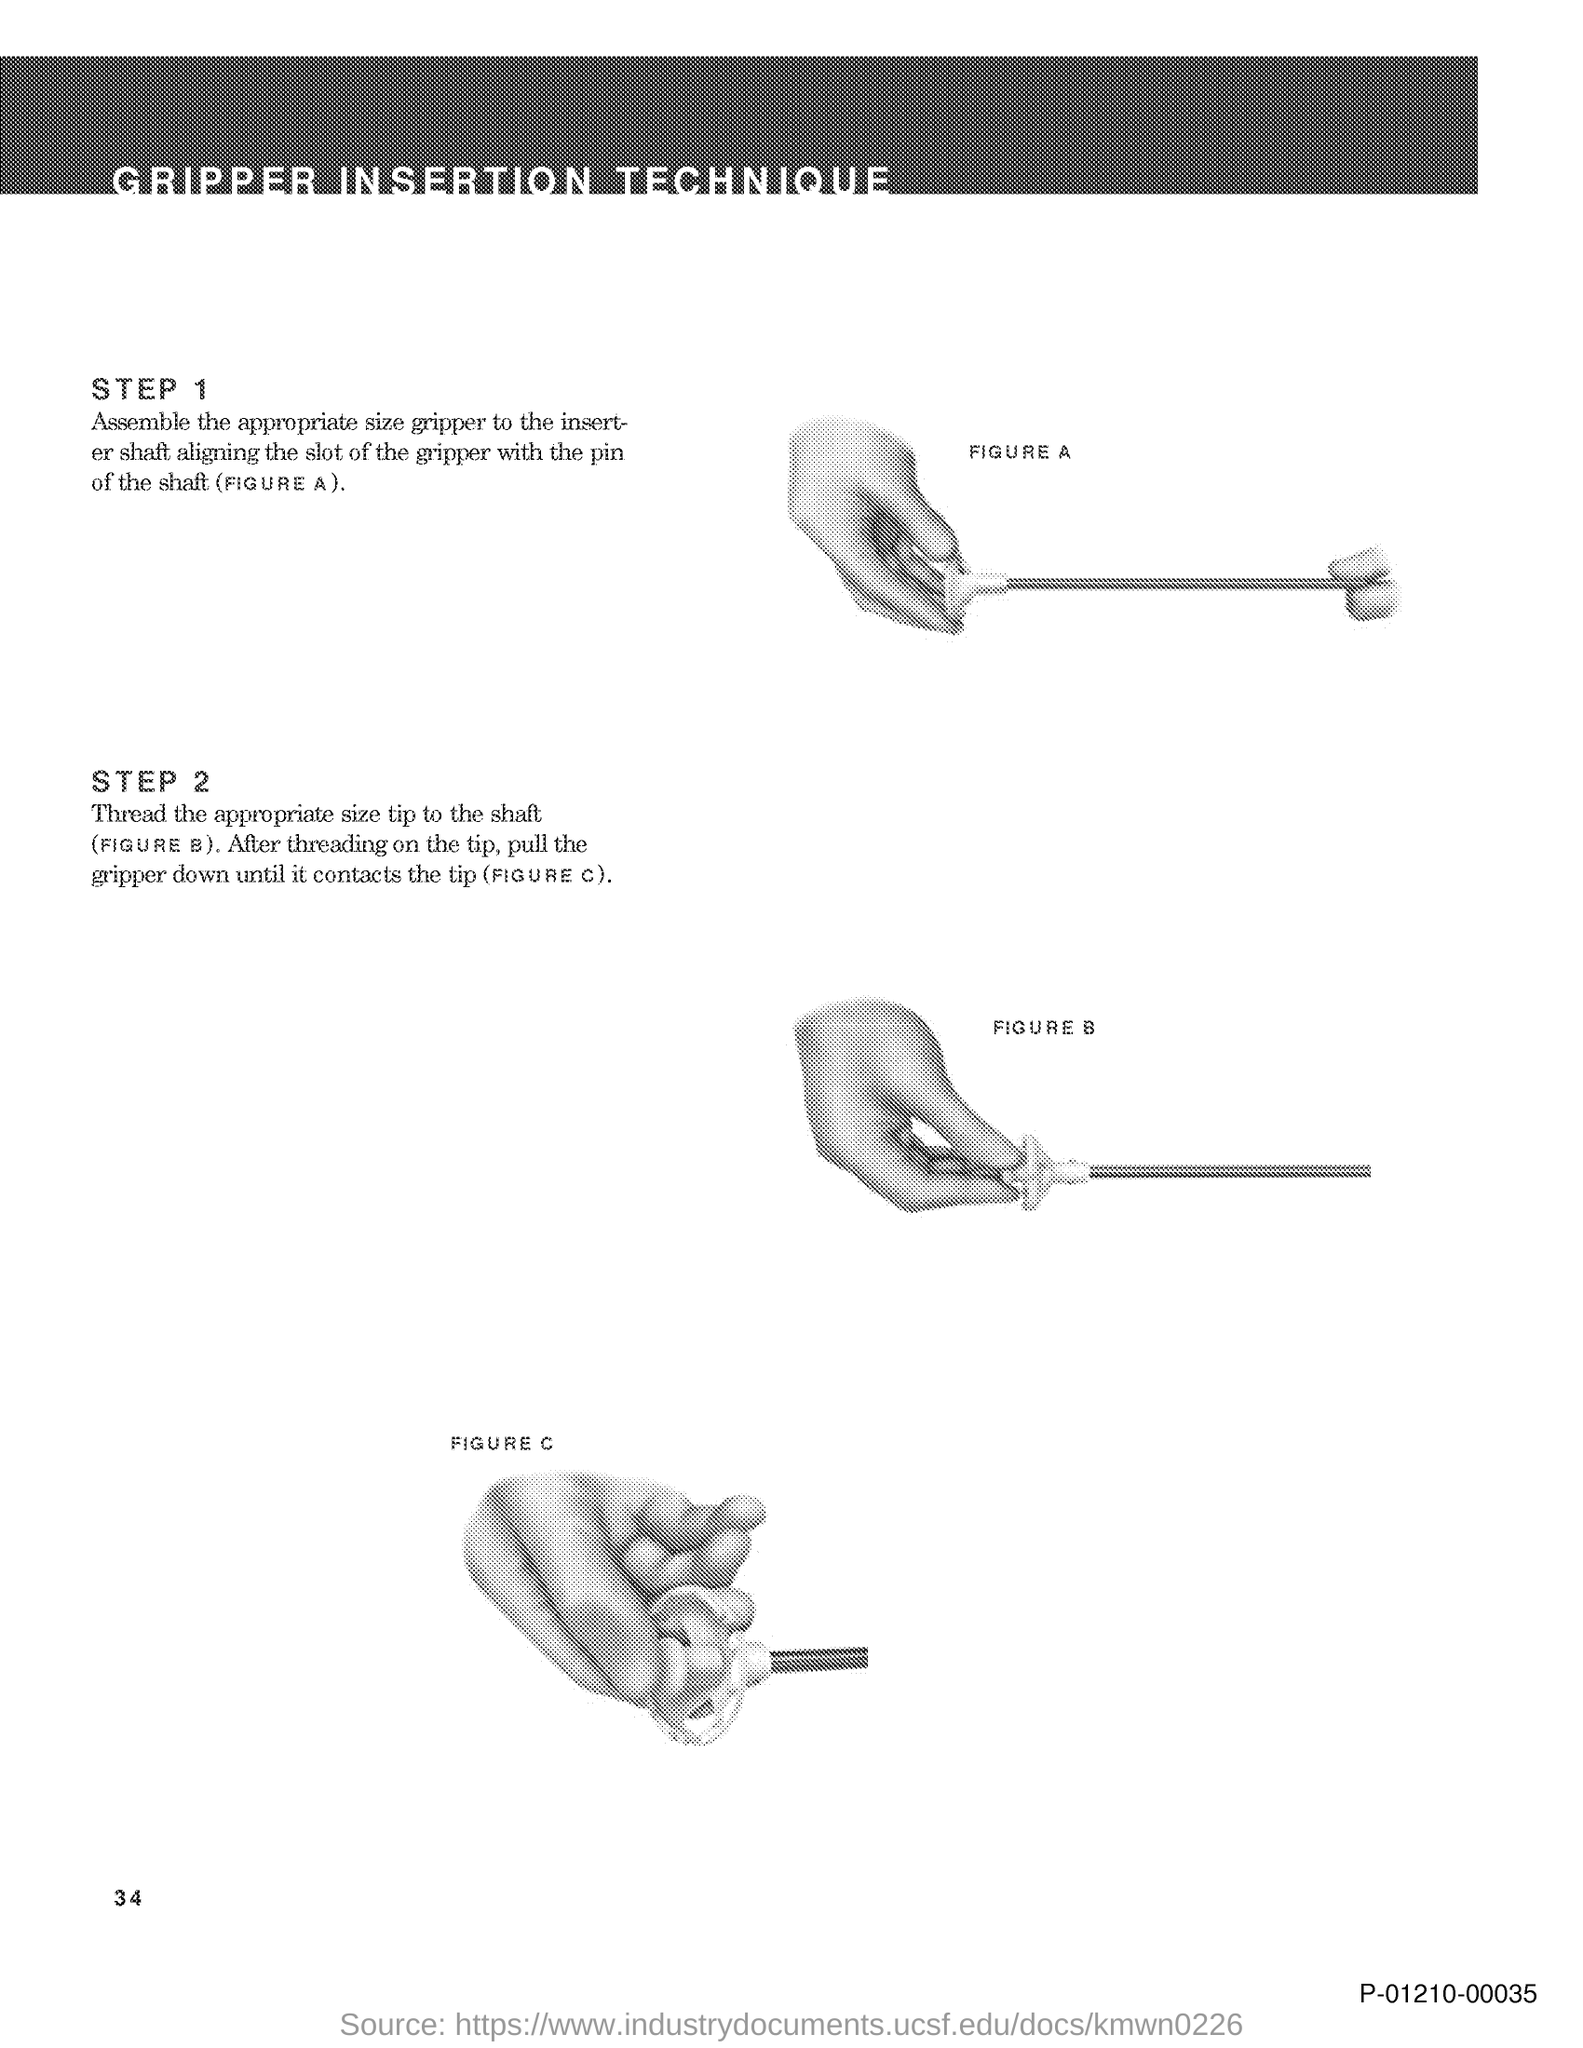Indicate a few pertinent items in this graphic. The document's title is Gripper Insertion Technique. The page number is 34. 